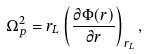<formula> <loc_0><loc_0><loc_500><loc_500>\Omega _ { p } ^ { 2 } = r _ { L } \left ( \frac { \partial \Phi ( r ) } { \partial r } \right ) _ { r _ { L } } ,</formula> 